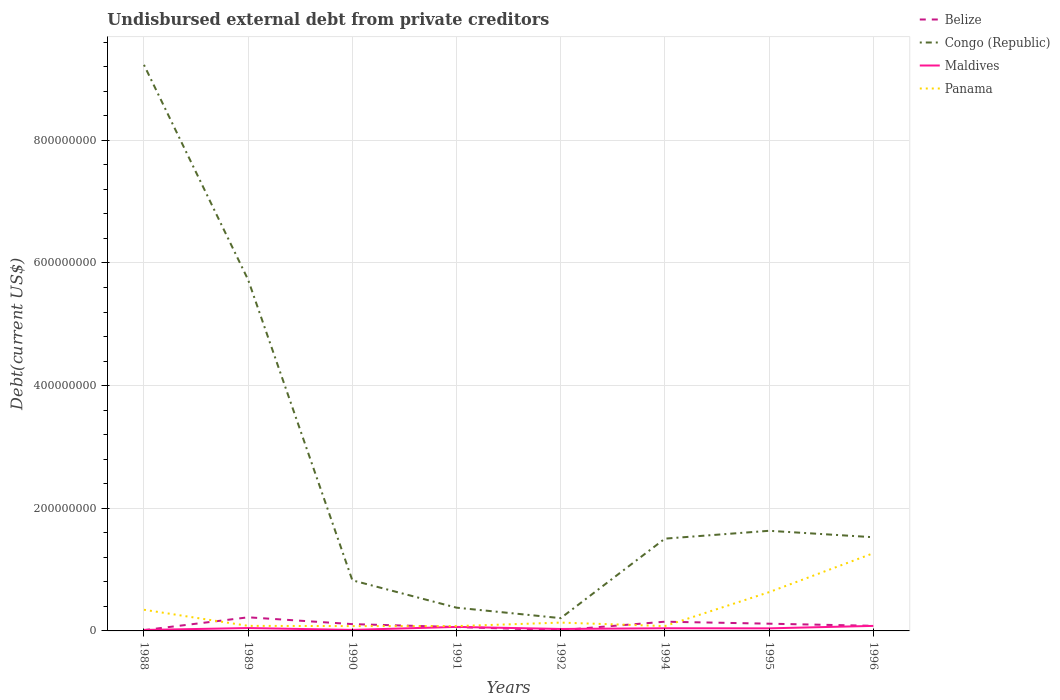Does the line corresponding to Belize intersect with the line corresponding to Panama?
Offer a very short reply. Yes. Is the number of lines equal to the number of legend labels?
Ensure brevity in your answer.  Yes. Across all years, what is the maximum total debt in Belize?
Make the answer very short. 1.24e+06. In which year was the total debt in Belize maximum?
Provide a succinct answer. 1992. What is the total total debt in Congo (Republic) in the graph?
Offer a terse response. 4.46e+07. What is the difference between the highest and the second highest total debt in Belize?
Offer a terse response. 2.10e+07. Is the total debt in Maldives strictly greater than the total debt in Congo (Republic) over the years?
Make the answer very short. Yes. How many lines are there?
Your answer should be compact. 4. What is the difference between two consecutive major ticks on the Y-axis?
Offer a terse response. 2.00e+08. Are the values on the major ticks of Y-axis written in scientific E-notation?
Provide a succinct answer. No. Does the graph contain any zero values?
Ensure brevity in your answer.  No. How are the legend labels stacked?
Ensure brevity in your answer.  Vertical. What is the title of the graph?
Provide a succinct answer. Undisbursed external debt from private creditors. What is the label or title of the X-axis?
Your answer should be compact. Years. What is the label or title of the Y-axis?
Ensure brevity in your answer.  Debt(current US$). What is the Debt(current US$) in Belize in 1988?
Keep it short and to the point. 1.32e+06. What is the Debt(current US$) in Congo (Republic) in 1988?
Offer a terse response. 9.23e+08. What is the Debt(current US$) in Maldives in 1988?
Provide a succinct answer. 1.58e+06. What is the Debt(current US$) of Panama in 1988?
Your answer should be very brief. 3.45e+07. What is the Debt(current US$) in Belize in 1989?
Keep it short and to the point. 2.22e+07. What is the Debt(current US$) of Congo (Republic) in 1989?
Your answer should be very brief. 5.72e+08. What is the Debt(current US$) of Maldives in 1989?
Your answer should be very brief. 4.68e+06. What is the Debt(current US$) of Panama in 1989?
Make the answer very short. 8.26e+06. What is the Debt(current US$) of Belize in 1990?
Keep it short and to the point. 1.11e+07. What is the Debt(current US$) of Congo (Republic) in 1990?
Your response must be concise. 8.25e+07. What is the Debt(current US$) of Maldives in 1990?
Keep it short and to the point. 1.69e+06. What is the Debt(current US$) in Panama in 1990?
Your response must be concise. 7.85e+06. What is the Debt(current US$) in Belize in 1991?
Give a very brief answer. 6.34e+06. What is the Debt(current US$) of Congo (Republic) in 1991?
Your response must be concise. 3.79e+07. What is the Debt(current US$) in Maldives in 1991?
Ensure brevity in your answer.  6.54e+06. What is the Debt(current US$) in Panama in 1991?
Your answer should be compact. 7.85e+06. What is the Debt(current US$) of Belize in 1992?
Give a very brief answer. 1.24e+06. What is the Debt(current US$) in Congo (Republic) in 1992?
Offer a terse response. 2.08e+07. What is the Debt(current US$) of Maldives in 1992?
Your answer should be very brief. 3.19e+06. What is the Debt(current US$) of Panama in 1992?
Ensure brevity in your answer.  1.36e+07. What is the Debt(current US$) in Belize in 1994?
Keep it short and to the point. 1.50e+07. What is the Debt(current US$) in Congo (Republic) in 1994?
Ensure brevity in your answer.  1.50e+08. What is the Debt(current US$) in Maldives in 1994?
Offer a very short reply. 4.35e+06. What is the Debt(current US$) in Panama in 1994?
Make the answer very short. 7.92e+06. What is the Debt(current US$) of Belize in 1995?
Your answer should be very brief. 1.18e+07. What is the Debt(current US$) in Congo (Republic) in 1995?
Your response must be concise. 1.63e+08. What is the Debt(current US$) in Maldives in 1995?
Make the answer very short. 4.20e+06. What is the Debt(current US$) of Panama in 1995?
Make the answer very short. 6.32e+07. What is the Debt(current US$) in Belize in 1996?
Your response must be concise. 8.32e+06. What is the Debt(current US$) in Congo (Republic) in 1996?
Give a very brief answer. 1.53e+08. What is the Debt(current US$) in Maldives in 1996?
Keep it short and to the point. 8.20e+06. What is the Debt(current US$) of Panama in 1996?
Offer a terse response. 1.27e+08. Across all years, what is the maximum Debt(current US$) in Belize?
Offer a terse response. 2.22e+07. Across all years, what is the maximum Debt(current US$) in Congo (Republic)?
Keep it short and to the point. 9.23e+08. Across all years, what is the maximum Debt(current US$) in Maldives?
Your response must be concise. 8.20e+06. Across all years, what is the maximum Debt(current US$) of Panama?
Give a very brief answer. 1.27e+08. Across all years, what is the minimum Debt(current US$) of Belize?
Your answer should be very brief. 1.24e+06. Across all years, what is the minimum Debt(current US$) in Congo (Republic)?
Keep it short and to the point. 2.08e+07. Across all years, what is the minimum Debt(current US$) in Maldives?
Ensure brevity in your answer.  1.58e+06. Across all years, what is the minimum Debt(current US$) in Panama?
Offer a very short reply. 7.85e+06. What is the total Debt(current US$) in Belize in the graph?
Offer a terse response. 7.74e+07. What is the total Debt(current US$) in Congo (Republic) in the graph?
Your answer should be compact. 2.10e+09. What is the total Debt(current US$) in Maldives in the graph?
Offer a terse response. 3.44e+07. What is the total Debt(current US$) in Panama in the graph?
Offer a terse response. 2.70e+08. What is the difference between the Debt(current US$) of Belize in 1988 and that in 1989?
Provide a succinct answer. -2.09e+07. What is the difference between the Debt(current US$) of Congo (Republic) in 1988 and that in 1989?
Provide a succinct answer. 3.51e+08. What is the difference between the Debt(current US$) in Maldives in 1988 and that in 1989?
Ensure brevity in your answer.  -3.10e+06. What is the difference between the Debt(current US$) of Panama in 1988 and that in 1989?
Your response must be concise. 2.62e+07. What is the difference between the Debt(current US$) of Belize in 1988 and that in 1990?
Your response must be concise. -9.77e+06. What is the difference between the Debt(current US$) of Congo (Republic) in 1988 and that in 1990?
Make the answer very short. 8.41e+08. What is the difference between the Debt(current US$) of Maldives in 1988 and that in 1990?
Offer a terse response. -1.04e+05. What is the difference between the Debt(current US$) of Panama in 1988 and that in 1990?
Offer a very short reply. 2.67e+07. What is the difference between the Debt(current US$) in Belize in 1988 and that in 1991?
Give a very brief answer. -5.02e+06. What is the difference between the Debt(current US$) in Congo (Republic) in 1988 and that in 1991?
Make the answer very short. 8.85e+08. What is the difference between the Debt(current US$) of Maldives in 1988 and that in 1991?
Your answer should be very brief. -4.96e+06. What is the difference between the Debt(current US$) of Panama in 1988 and that in 1991?
Make the answer very short. 2.67e+07. What is the difference between the Debt(current US$) in Belize in 1988 and that in 1992?
Your response must be concise. 8.10e+04. What is the difference between the Debt(current US$) in Congo (Republic) in 1988 and that in 1992?
Keep it short and to the point. 9.02e+08. What is the difference between the Debt(current US$) of Maldives in 1988 and that in 1992?
Provide a short and direct response. -1.60e+06. What is the difference between the Debt(current US$) of Panama in 1988 and that in 1992?
Provide a succinct answer. 2.09e+07. What is the difference between the Debt(current US$) in Belize in 1988 and that in 1994?
Provide a succinct answer. -1.37e+07. What is the difference between the Debt(current US$) of Congo (Republic) in 1988 and that in 1994?
Give a very brief answer. 7.73e+08. What is the difference between the Debt(current US$) of Maldives in 1988 and that in 1994?
Make the answer very short. -2.76e+06. What is the difference between the Debt(current US$) of Panama in 1988 and that in 1994?
Keep it short and to the point. 2.66e+07. What is the difference between the Debt(current US$) of Belize in 1988 and that in 1995?
Provide a succinct answer. -1.05e+07. What is the difference between the Debt(current US$) in Congo (Republic) in 1988 and that in 1995?
Offer a terse response. 7.60e+08. What is the difference between the Debt(current US$) of Maldives in 1988 and that in 1995?
Offer a terse response. -2.61e+06. What is the difference between the Debt(current US$) in Panama in 1988 and that in 1995?
Your answer should be compact. -2.87e+07. What is the difference between the Debt(current US$) of Belize in 1988 and that in 1996?
Provide a succinct answer. -7.00e+06. What is the difference between the Debt(current US$) of Congo (Republic) in 1988 and that in 1996?
Your answer should be very brief. 7.70e+08. What is the difference between the Debt(current US$) of Maldives in 1988 and that in 1996?
Your answer should be very brief. -6.62e+06. What is the difference between the Debt(current US$) in Panama in 1988 and that in 1996?
Offer a terse response. -9.22e+07. What is the difference between the Debt(current US$) of Belize in 1989 and that in 1990?
Keep it short and to the point. 1.11e+07. What is the difference between the Debt(current US$) of Congo (Republic) in 1989 and that in 1990?
Ensure brevity in your answer.  4.90e+08. What is the difference between the Debt(current US$) of Maldives in 1989 and that in 1990?
Provide a succinct answer. 3.00e+06. What is the difference between the Debt(current US$) in Panama in 1989 and that in 1990?
Your answer should be compact. 4.11e+05. What is the difference between the Debt(current US$) of Belize in 1989 and that in 1991?
Make the answer very short. 1.59e+07. What is the difference between the Debt(current US$) of Congo (Republic) in 1989 and that in 1991?
Provide a succinct answer. 5.35e+08. What is the difference between the Debt(current US$) of Maldives in 1989 and that in 1991?
Ensure brevity in your answer.  -1.86e+06. What is the difference between the Debt(current US$) of Panama in 1989 and that in 1991?
Ensure brevity in your answer.  4.18e+05. What is the difference between the Debt(current US$) in Belize in 1989 and that in 1992?
Make the answer very short. 2.10e+07. What is the difference between the Debt(current US$) of Congo (Republic) in 1989 and that in 1992?
Provide a succinct answer. 5.52e+08. What is the difference between the Debt(current US$) of Maldives in 1989 and that in 1992?
Give a very brief answer. 1.50e+06. What is the difference between the Debt(current US$) of Panama in 1989 and that in 1992?
Your response must be concise. -5.31e+06. What is the difference between the Debt(current US$) of Belize in 1989 and that in 1994?
Ensure brevity in your answer.  7.16e+06. What is the difference between the Debt(current US$) of Congo (Republic) in 1989 and that in 1994?
Your answer should be compact. 4.22e+08. What is the difference between the Debt(current US$) of Maldives in 1989 and that in 1994?
Provide a succinct answer. 3.34e+05. What is the difference between the Debt(current US$) of Panama in 1989 and that in 1994?
Give a very brief answer. 3.43e+05. What is the difference between the Debt(current US$) of Belize in 1989 and that in 1995?
Your answer should be very brief. 1.04e+07. What is the difference between the Debt(current US$) in Congo (Republic) in 1989 and that in 1995?
Your answer should be compact. 4.09e+08. What is the difference between the Debt(current US$) in Maldives in 1989 and that in 1995?
Provide a short and direct response. 4.89e+05. What is the difference between the Debt(current US$) of Panama in 1989 and that in 1995?
Your response must be concise. -5.50e+07. What is the difference between the Debt(current US$) of Belize in 1989 and that in 1996?
Offer a terse response. 1.39e+07. What is the difference between the Debt(current US$) of Congo (Republic) in 1989 and that in 1996?
Your answer should be compact. 4.20e+08. What is the difference between the Debt(current US$) of Maldives in 1989 and that in 1996?
Give a very brief answer. -3.52e+06. What is the difference between the Debt(current US$) of Panama in 1989 and that in 1996?
Offer a very short reply. -1.18e+08. What is the difference between the Debt(current US$) of Belize in 1990 and that in 1991?
Your response must be concise. 4.75e+06. What is the difference between the Debt(current US$) in Congo (Republic) in 1990 and that in 1991?
Offer a terse response. 4.46e+07. What is the difference between the Debt(current US$) of Maldives in 1990 and that in 1991?
Offer a very short reply. -4.85e+06. What is the difference between the Debt(current US$) in Panama in 1990 and that in 1991?
Offer a terse response. 7000. What is the difference between the Debt(current US$) of Belize in 1990 and that in 1992?
Ensure brevity in your answer.  9.85e+06. What is the difference between the Debt(current US$) in Congo (Republic) in 1990 and that in 1992?
Provide a succinct answer. 6.17e+07. What is the difference between the Debt(current US$) in Maldives in 1990 and that in 1992?
Offer a very short reply. -1.50e+06. What is the difference between the Debt(current US$) in Panama in 1990 and that in 1992?
Offer a very short reply. -5.72e+06. What is the difference between the Debt(current US$) of Belize in 1990 and that in 1994?
Offer a terse response. -3.96e+06. What is the difference between the Debt(current US$) in Congo (Republic) in 1990 and that in 1994?
Make the answer very short. -6.80e+07. What is the difference between the Debt(current US$) of Maldives in 1990 and that in 1994?
Keep it short and to the point. -2.66e+06. What is the difference between the Debt(current US$) in Panama in 1990 and that in 1994?
Provide a short and direct response. -6.80e+04. What is the difference between the Debt(current US$) of Belize in 1990 and that in 1995?
Your response must be concise. -7.07e+05. What is the difference between the Debt(current US$) in Congo (Republic) in 1990 and that in 1995?
Offer a very short reply. -8.08e+07. What is the difference between the Debt(current US$) of Maldives in 1990 and that in 1995?
Give a very brief answer. -2.51e+06. What is the difference between the Debt(current US$) in Panama in 1990 and that in 1995?
Your answer should be very brief. -5.54e+07. What is the difference between the Debt(current US$) in Belize in 1990 and that in 1996?
Offer a terse response. 2.77e+06. What is the difference between the Debt(current US$) of Congo (Republic) in 1990 and that in 1996?
Make the answer very short. -7.03e+07. What is the difference between the Debt(current US$) in Maldives in 1990 and that in 1996?
Provide a short and direct response. -6.51e+06. What is the difference between the Debt(current US$) of Panama in 1990 and that in 1996?
Your answer should be compact. -1.19e+08. What is the difference between the Debt(current US$) of Belize in 1991 and that in 1992?
Provide a short and direct response. 5.10e+06. What is the difference between the Debt(current US$) of Congo (Republic) in 1991 and that in 1992?
Make the answer very short. 1.71e+07. What is the difference between the Debt(current US$) in Maldives in 1991 and that in 1992?
Offer a very short reply. 3.35e+06. What is the difference between the Debt(current US$) of Panama in 1991 and that in 1992?
Make the answer very short. -5.73e+06. What is the difference between the Debt(current US$) of Belize in 1991 and that in 1994?
Offer a terse response. -8.70e+06. What is the difference between the Debt(current US$) of Congo (Republic) in 1991 and that in 1994?
Offer a very short reply. -1.13e+08. What is the difference between the Debt(current US$) in Maldives in 1991 and that in 1994?
Your answer should be compact. 2.19e+06. What is the difference between the Debt(current US$) of Panama in 1991 and that in 1994?
Keep it short and to the point. -7.50e+04. What is the difference between the Debt(current US$) in Belize in 1991 and that in 1995?
Your response must be concise. -5.46e+06. What is the difference between the Debt(current US$) in Congo (Republic) in 1991 and that in 1995?
Offer a terse response. -1.25e+08. What is the difference between the Debt(current US$) of Maldives in 1991 and that in 1995?
Offer a very short reply. 2.35e+06. What is the difference between the Debt(current US$) in Panama in 1991 and that in 1995?
Provide a succinct answer. -5.54e+07. What is the difference between the Debt(current US$) in Belize in 1991 and that in 1996?
Your answer should be very brief. -1.98e+06. What is the difference between the Debt(current US$) in Congo (Republic) in 1991 and that in 1996?
Keep it short and to the point. -1.15e+08. What is the difference between the Debt(current US$) of Maldives in 1991 and that in 1996?
Your answer should be very brief. -1.66e+06. What is the difference between the Debt(current US$) in Panama in 1991 and that in 1996?
Your response must be concise. -1.19e+08. What is the difference between the Debt(current US$) of Belize in 1992 and that in 1994?
Offer a very short reply. -1.38e+07. What is the difference between the Debt(current US$) of Congo (Republic) in 1992 and that in 1994?
Provide a short and direct response. -1.30e+08. What is the difference between the Debt(current US$) of Maldives in 1992 and that in 1994?
Your response must be concise. -1.16e+06. What is the difference between the Debt(current US$) of Panama in 1992 and that in 1994?
Offer a very short reply. 5.66e+06. What is the difference between the Debt(current US$) of Belize in 1992 and that in 1995?
Your response must be concise. -1.06e+07. What is the difference between the Debt(current US$) in Congo (Republic) in 1992 and that in 1995?
Ensure brevity in your answer.  -1.42e+08. What is the difference between the Debt(current US$) of Maldives in 1992 and that in 1995?
Keep it short and to the point. -1.01e+06. What is the difference between the Debt(current US$) of Panama in 1992 and that in 1995?
Your answer should be compact. -4.96e+07. What is the difference between the Debt(current US$) in Belize in 1992 and that in 1996?
Your response must be concise. -7.08e+06. What is the difference between the Debt(current US$) of Congo (Republic) in 1992 and that in 1996?
Your response must be concise. -1.32e+08. What is the difference between the Debt(current US$) in Maldives in 1992 and that in 1996?
Offer a very short reply. -5.01e+06. What is the difference between the Debt(current US$) of Panama in 1992 and that in 1996?
Your response must be concise. -1.13e+08. What is the difference between the Debt(current US$) of Belize in 1994 and that in 1995?
Your answer should be compact. 3.25e+06. What is the difference between the Debt(current US$) in Congo (Republic) in 1994 and that in 1995?
Your answer should be very brief. -1.28e+07. What is the difference between the Debt(current US$) in Maldives in 1994 and that in 1995?
Give a very brief answer. 1.55e+05. What is the difference between the Debt(current US$) in Panama in 1994 and that in 1995?
Give a very brief answer. -5.53e+07. What is the difference between the Debt(current US$) in Belize in 1994 and that in 1996?
Offer a terse response. 6.72e+06. What is the difference between the Debt(current US$) in Congo (Republic) in 1994 and that in 1996?
Provide a succinct answer. -2.27e+06. What is the difference between the Debt(current US$) in Maldives in 1994 and that in 1996?
Make the answer very short. -3.85e+06. What is the difference between the Debt(current US$) of Panama in 1994 and that in 1996?
Keep it short and to the point. -1.19e+08. What is the difference between the Debt(current US$) of Belize in 1995 and that in 1996?
Provide a succinct answer. 3.47e+06. What is the difference between the Debt(current US$) of Congo (Republic) in 1995 and that in 1996?
Offer a very short reply. 1.05e+07. What is the difference between the Debt(current US$) of Maldives in 1995 and that in 1996?
Your answer should be very brief. -4.01e+06. What is the difference between the Debt(current US$) in Panama in 1995 and that in 1996?
Your answer should be very brief. -6.35e+07. What is the difference between the Debt(current US$) in Belize in 1988 and the Debt(current US$) in Congo (Republic) in 1989?
Offer a very short reply. -5.71e+08. What is the difference between the Debt(current US$) in Belize in 1988 and the Debt(current US$) in Maldives in 1989?
Provide a succinct answer. -3.36e+06. What is the difference between the Debt(current US$) of Belize in 1988 and the Debt(current US$) of Panama in 1989?
Offer a very short reply. -6.94e+06. What is the difference between the Debt(current US$) of Congo (Republic) in 1988 and the Debt(current US$) of Maldives in 1989?
Provide a succinct answer. 9.18e+08. What is the difference between the Debt(current US$) of Congo (Republic) in 1988 and the Debt(current US$) of Panama in 1989?
Give a very brief answer. 9.15e+08. What is the difference between the Debt(current US$) of Maldives in 1988 and the Debt(current US$) of Panama in 1989?
Provide a succinct answer. -6.68e+06. What is the difference between the Debt(current US$) in Belize in 1988 and the Debt(current US$) in Congo (Republic) in 1990?
Make the answer very short. -8.12e+07. What is the difference between the Debt(current US$) in Belize in 1988 and the Debt(current US$) in Maldives in 1990?
Your response must be concise. -3.68e+05. What is the difference between the Debt(current US$) in Belize in 1988 and the Debt(current US$) in Panama in 1990?
Your answer should be very brief. -6.53e+06. What is the difference between the Debt(current US$) of Congo (Republic) in 1988 and the Debt(current US$) of Maldives in 1990?
Ensure brevity in your answer.  9.21e+08. What is the difference between the Debt(current US$) in Congo (Republic) in 1988 and the Debt(current US$) in Panama in 1990?
Provide a succinct answer. 9.15e+08. What is the difference between the Debt(current US$) of Maldives in 1988 and the Debt(current US$) of Panama in 1990?
Offer a terse response. -6.27e+06. What is the difference between the Debt(current US$) in Belize in 1988 and the Debt(current US$) in Congo (Republic) in 1991?
Give a very brief answer. -3.66e+07. What is the difference between the Debt(current US$) of Belize in 1988 and the Debt(current US$) of Maldives in 1991?
Your answer should be compact. -5.22e+06. What is the difference between the Debt(current US$) in Belize in 1988 and the Debt(current US$) in Panama in 1991?
Your answer should be compact. -6.53e+06. What is the difference between the Debt(current US$) in Congo (Republic) in 1988 and the Debt(current US$) in Maldives in 1991?
Ensure brevity in your answer.  9.16e+08. What is the difference between the Debt(current US$) in Congo (Republic) in 1988 and the Debt(current US$) in Panama in 1991?
Make the answer very short. 9.15e+08. What is the difference between the Debt(current US$) in Maldives in 1988 and the Debt(current US$) in Panama in 1991?
Ensure brevity in your answer.  -6.26e+06. What is the difference between the Debt(current US$) in Belize in 1988 and the Debt(current US$) in Congo (Republic) in 1992?
Your response must be concise. -1.95e+07. What is the difference between the Debt(current US$) in Belize in 1988 and the Debt(current US$) in Maldives in 1992?
Your answer should be compact. -1.87e+06. What is the difference between the Debt(current US$) in Belize in 1988 and the Debt(current US$) in Panama in 1992?
Your response must be concise. -1.23e+07. What is the difference between the Debt(current US$) of Congo (Republic) in 1988 and the Debt(current US$) of Maldives in 1992?
Provide a succinct answer. 9.20e+08. What is the difference between the Debt(current US$) in Congo (Republic) in 1988 and the Debt(current US$) in Panama in 1992?
Keep it short and to the point. 9.09e+08. What is the difference between the Debt(current US$) in Maldives in 1988 and the Debt(current US$) in Panama in 1992?
Make the answer very short. -1.20e+07. What is the difference between the Debt(current US$) of Belize in 1988 and the Debt(current US$) of Congo (Republic) in 1994?
Offer a terse response. -1.49e+08. What is the difference between the Debt(current US$) of Belize in 1988 and the Debt(current US$) of Maldives in 1994?
Make the answer very short. -3.03e+06. What is the difference between the Debt(current US$) of Belize in 1988 and the Debt(current US$) of Panama in 1994?
Your answer should be very brief. -6.60e+06. What is the difference between the Debt(current US$) of Congo (Republic) in 1988 and the Debt(current US$) of Maldives in 1994?
Your answer should be compact. 9.19e+08. What is the difference between the Debt(current US$) of Congo (Republic) in 1988 and the Debt(current US$) of Panama in 1994?
Give a very brief answer. 9.15e+08. What is the difference between the Debt(current US$) in Maldives in 1988 and the Debt(current US$) in Panama in 1994?
Your response must be concise. -6.34e+06. What is the difference between the Debt(current US$) in Belize in 1988 and the Debt(current US$) in Congo (Republic) in 1995?
Offer a terse response. -1.62e+08. What is the difference between the Debt(current US$) in Belize in 1988 and the Debt(current US$) in Maldives in 1995?
Ensure brevity in your answer.  -2.87e+06. What is the difference between the Debt(current US$) in Belize in 1988 and the Debt(current US$) in Panama in 1995?
Ensure brevity in your answer.  -6.19e+07. What is the difference between the Debt(current US$) of Congo (Republic) in 1988 and the Debt(current US$) of Maldives in 1995?
Your answer should be compact. 9.19e+08. What is the difference between the Debt(current US$) of Congo (Republic) in 1988 and the Debt(current US$) of Panama in 1995?
Your answer should be very brief. 8.60e+08. What is the difference between the Debt(current US$) in Maldives in 1988 and the Debt(current US$) in Panama in 1995?
Your answer should be very brief. -6.16e+07. What is the difference between the Debt(current US$) of Belize in 1988 and the Debt(current US$) of Congo (Republic) in 1996?
Keep it short and to the point. -1.51e+08. What is the difference between the Debt(current US$) of Belize in 1988 and the Debt(current US$) of Maldives in 1996?
Your response must be concise. -6.88e+06. What is the difference between the Debt(current US$) in Belize in 1988 and the Debt(current US$) in Panama in 1996?
Provide a succinct answer. -1.25e+08. What is the difference between the Debt(current US$) of Congo (Republic) in 1988 and the Debt(current US$) of Maldives in 1996?
Your answer should be very brief. 9.15e+08. What is the difference between the Debt(current US$) of Congo (Republic) in 1988 and the Debt(current US$) of Panama in 1996?
Offer a terse response. 7.96e+08. What is the difference between the Debt(current US$) of Maldives in 1988 and the Debt(current US$) of Panama in 1996?
Provide a succinct answer. -1.25e+08. What is the difference between the Debt(current US$) of Belize in 1989 and the Debt(current US$) of Congo (Republic) in 1990?
Make the answer very short. -6.03e+07. What is the difference between the Debt(current US$) in Belize in 1989 and the Debt(current US$) in Maldives in 1990?
Offer a very short reply. 2.05e+07. What is the difference between the Debt(current US$) in Belize in 1989 and the Debt(current US$) in Panama in 1990?
Your answer should be compact. 1.43e+07. What is the difference between the Debt(current US$) in Congo (Republic) in 1989 and the Debt(current US$) in Maldives in 1990?
Offer a terse response. 5.71e+08. What is the difference between the Debt(current US$) of Congo (Republic) in 1989 and the Debt(current US$) of Panama in 1990?
Your answer should be compact. 5.65e+08. What is the difference between the Debt(current US$) in Maldives in 1989 and the Debt(current US$) in Panama in 1990?
Your answer should be very brief. -3.17e+06. What is the difference between the Debt(current US$) of Belize in 1989 and the Debt(current US$) of Congo (Republic) in 1991?
Provide a succinct answer. -1.57e+07. What is the difference between the Debt(current US$) in Belize in 1989 and the Debt(current US$) in Maldives in 1991?
Keep it short and to the point. 1.57e+07. What is the difference between the Debt(current US$) of Belize in 1989 and the Debt(current US$) of Panama in 1991?
Offer a terse response. 1.44e+07. What is the difference between the Debt(current US$) of Congo (Republic) in 1989 and the Debt(current US$) of Maldives in 1991?
Your answer should be compact. 5.66e+08. What is the difference between the Debt(current US$) of Congo (Republic) in 1989 and the Debt(current US$) of Panama in 1991?
Make the answer very short. 5.65e+08. What is the difference between the Debt(current US$) in Maldives in 1989 and the Debt(current US$) in Panama in 1991?
Give a very brief answer. -3.16e+06. What is the difference between the Debt(current US$) in Belize in 1989 and the Debt(current US$) in Congo (Republic) in 1992?
Keep it short and to the point. 1.36e+06. What is the difference between the Debt(current US$) of Belize in 1989 and the Debt(current US$) of Maldives in 1992?
Make the answer very short. 1.90e+07. What is the difference between the Debt(current US$) in Belize in 1989 and the Debt(current US$) in Panama in 1992?
Give a very brief answer. 8.62e+06. What is the difference between the Debt(current US$) of Congo (Republic) in 1989 and the Debt(current US$) of Maldives in 1992?
Give a very brief answer. 5.69e+08. What is the difference between the Debt(current US$) in Congo (Republic) in 1989 and the Debt(current US$) in Panama in 1992?
Give a very brief answer. 5.59e+08. What is the difference between the Debt(current US$) of Maldives in 1989 and the Debt(current US$) of Panama in 1992?
Give a very brief answer. -8.89e+06. What is the difference between the Debt(current US$) of Belize in 1989 and the Debt(current US$) of Congo (Republic) in 1994?
Your response must be concise. -1.28e+08. What is the difference between the Debt(current US$) of Belize in 1989 and the Debt(current US$) of Maldives in 1994?
Your response must be concise. 1.78e+07. What is the difference between the Debt(current US$) of Belize in 1989 and the Debt(current US$) of Panama in 1994?
Your answer should be compact. 1.43e+07. What is the difference between the Debt(current US$) of Congo (Republic) in 1989 and the Debt(current US$) of Maldives in 1994?
Provide a short and direct response. 5.68e+08. What is the difference between the Debt(current US$) of Congo (Republic) in 1989 and the Debt(current US$) of Panama in 1994?
Your response must be concise. 5.65e+08. What is the difference between the Debt(current US$) of Maldives in 1989 and the Debt(current US$) of Panama in 1994?
Give a very brief answer. -3.24e+06. What is the difference between the Debt(current US$) in Belize in 1989 and the Debt(current US$) in Congo (Republic) in 1995?
Ensure brevity in your answer.  -1.41e+08. What is the difference between the Debt(current US$) of Belize in 1989 and the Debt(current US$) of Maldives in 1995?
Provide a short and direct response. 1.80e+07. What is the difference between the Debt(current US$) in Belize in 1989 and the Debt(current US$) in Panama in 1995?
Make the answer very short. -4.10e+07. What is the difference between the Debt(current US$) in Congo (Republic) in 1989 and the Debt(current US$) in Maldives in 1995?
Ensure brevity in your answer.  5.68e+08. What is the difference between the Debt(current US$) in Congo (Republic) in 1989 and the Debt(current US$) in Panama in 1995?
Give a very brief answer. 5.09e+08. What is the difference between the Debt(current US$) of Maldives in 1989 and the Debt(current US$) of Panama in 1995?
Ensure brevity in your answer.  -5.85e+07. What is the difference between the Debt(current US$) of Belize in 1989 and the Debt(current US$) of Congo (Republic) in 1996?
Offer a very short reply. -1.31e+08. What is the difference between the Debt(current US$) of Belize in 1989 and the Debt(current US$) of Maldives in 1996?
Provide a short and direct response. 1.40e+07. What is the difference between the Debt(current US$) in Belize in 1989 and the Debt(current US$) in Panama in 1996?
Provide a short and direct response. -1.04e+08. What is the difference between the Debt(current US$) of Congo (Republic) in 1989 and the Debt(current US$) of Maldives in 1996?
Your response must be concise. 5.64e+08. What is the difference between the Debt(current US$) of Congo (Republic) in 1989 and the Debt(current US$) of Panama in 1996?
Your answer should be compact. 4.46e+08. What is the difference between the Debt(current US$) in Maldives in 1989 and the Debt(current US$) in Panama in 1996?
Keep it short and to the point. -1.22e+08. What is the difference between the Debt(current US$) of Belize in 1990 and the Debt(current US$) of Congo (Republic) in 1991?
Offer a terse response. -2.68e+07. What is the difference between the Debt(current US$) of Belize in 1990 and the Debt(current US$) of Maldives in 1991?
Provide a succinct answer. 4.55e+06. What is the difference between the Debt(current US$) of Belize in 1990 and the Debt(current US$) of Panama in 1991?
Give a very brief answer. 3.24e+06. What is the difference between the Debt(current US$) of Congo (Republic) in 1990 and the Debt(current US$) of Maldives in 1991?
Make the answer very short. 7.60e+07. What is the difference between the Debt(current US$) in Congo (Republic) in 1990 and the Debt(current US$) in Panama in 1991?
Your answer should be compact. 7.47e+07. What is the difference between the Debt(current US$) in Maldives in 1990 and the Debt(current US$) in Panama in 1991?
Make the answer very short. -6.16e+06. What is the difference between the Debt(current US$) of Belize in 1990 and the Debt(current US$) of Congo (Republic) in 1992?
Provide a succinct answer. -9.75e+06. What is the difference between the Debt(current US$) in Belize in 1990 and the Debt(current US$) in Maldives in 1992?
Offer a terse response. 7.90e+06. What is the difference between the Debt(current US$) of Belize in 1990 and the Debt(current US$) of Panama in 1992?
Your answer should be very brief. -2.49e+06. What is the difference between the Debt(current US$) in Congo (Republic) in 1990 and the Debt(current US$) in Maldives in 1992?
Your response must be concise. 7.93e+07. What is the difference between the Debt(current US$) in Congo (Republic) in 1990 and the Debt(current US$) in Panama in 1992?
Ensure brevity in your answer.  6.89e+07. What is the difference between the Debt(current US$) of Maldives in 1990 and the Debt(current US$) of Panama in 1992?
Provide a succinct answer. -1.19e+07. What is the difference between the Debt(current US$) in Belize in 1990 and the Debt(current US$) in Congo (Republic) in 1994?
Keep it short and to the point. -1.39e+08. What is the difference between the Debt(current US$) in Belize in 1990 and the Debt(current US$) in Maldives in 1994?
Your response must be concise. 6.74e+06. What is the difference between the Debt(current US$) in Belize in 1990 and the Debt(current US$) in Panama in 1994?
Your answer should be compact. 3.17e+06. What is the difference between the Debt(current US$) in Congo (Republic) in 1990 and the Debt(current US$) in Maldives in 1994?
Your answer should be very brief. 7.82e+07. What is the difference between the Debt(current US$) in Congo (Republic) in 1990 and the Debt(current US$) in Panama in 1994?
Your response must be concise. 7.46e+07. What is the difference between the Debt(current US$) of Maldives in 1990 and the Debt(current US$) of Panama in 1994?
Your answer should be compact. -6.23e+06. What is the difference between the Debt(current US$) of Belize in 1990 and the Debt(current US$) of Congo (Republic) in 1995?
Ensure brevity in your answer.  -1.52e+08. What is the difference between the Debt(current US$) of Belize in 1990 and the Debt(current US$) of Maldives in 1995?
Provide a succinct answer. 6.90e+06. What is the difference between the Debt(current US$) of Belize in 1990 and the Debt(current US$) of Panama in 1995?
Ensure brevity in your answer.  -5.21e+07. What is the difference between the Debt(current US$) in Congo (Republic) in 1990 and the Debt(current US$) in Maldives in 1995?
Your answer should be very brief. 7.83e+07. What is the difference between the Debt(current US$) of Congo (Republic) in 1990 and the Debt(current US$) of Panama in 1995?
Give a very brief answer. 1.93e+07. What is the difference between the Debt(current US$) in Maldives in 1990 and the Debt(current US$) in Panama in 1995?
Provide a succinct answer. -6.15e+07. What is the difference between the Debt(current US$) in Belize in 1990 and the Debt(current US$) in Congo (Republic) in 1996?
Provide a short and direct response. -1.42e+08. What is the difference between the Debt(current US$) of Belize in 1990 and the Debt(current US$) of Maldives in 1996?
Offer a very short reply. 2.89e+06. What is the difference between the Debt(current US$) in Belize in 1990 and the Debt(current US$) in Panama in 1996?
Your answer should be very brief. -1.16e+08. What is the difference between the Debt(current US$) of Congo (Republic) in 1990 and the Debt(current US$) of Maldives in 1996?
Provide a succinct answer. 7.43e+07. What is the difference between the Debt(current US$) in Congo (Republic) in 1990 and the Debt(current US$) in Panama in 1996?
Your response must be concise. -4.42e+07. What is the difference between the Debt(current US$) in Maldives in 1990 and the Debt(current US$) in Panama in 1996?
Provide a short and direct response. -1.25e+08. What is the difference between the Debt(current US$) in Belize in 1991 and the Debt(current US$) in Congo (Republic) in 1992?
Keep it short and to the point. -1.45e+07. What is the difference between the Debt(current US$) in Belize in 1991 and the Debt(current US$) in Maldives in 1992?
Provide a short and direct response. 3.15e+06. What is the difference between the Debt(current US$) of Belize in 1991 and the Debt(current US$) of Panama in 1992?
Keep it short and to the point. -7.24e+06. What is the difference between the Debt(current US$) of Congo (Republic) in 1991 and the Debt(current US$) of Maldives in 1992?
Provide a short and direct response. 3.47e+07. What is the difference between the Debt(current US$) of Congo (Republic) in 1991 and the Debt(current US$) of Panama in 1992?
Your response must be concise. 2.43e+07. What is the difference between the Debt(current US$) of Maldives in 1991 and the Debt(current US$) of Panama in 1992?
Your answer should be very brief. -7.04e+06. What is the difference between the Debt(current US$) of Belize in 1991 and the Debt(current US$) of Congo (Republic) in 1994?
Provide a short and direct response. -1.44e+08. What is the difference between the Debt(current US$) of Belize in 1991 and the Debt(current US$) of Maldives in 1994?
Make the answer very short. 1.99e+06. What is the difference between the Debt(current US$) of Belize in 1991 and the Debt(current US$) of Panama in 1994?
Ensure brevity in your answer.  -1.58e+06. What is the difference between the Debt(current US$) of Congo (Republic) in 1991 and the Debt(current US$) of Maldives in 1994?
Offer a very short reply. 3.36e+07. What is the difference between the Debt(current US$) in Congo (Republic) in 1991 and the Debt(current US$) in Panama in 1994?
Offer a very short reply. 3.00e+07. What is the difference between the Debt(current US$) of Maldives in 1991 and the Debt(current US$) of Panama in 1994?
Give a very brief answer. -1.38e+06. What is the difference between the Debt(current US$) of Belize in 1991 and the Debt(current US$) of Congo (Republic) in 1995?
Your answer should be compact. -1.57e+08. What is the difference between the Debt(current US$) in Belize in 1991 and the Debt(current US$) in Maldives in 1995?
Provide a succinct answer. 2.14e+06. What is the difference between the Debt(current US$) in Belize in 1991 and the Debt(current US$) in Panama in 1995?
Make the answer very short. -5.69e+07. What is the difference between the Debt(current US$) of Congo (Republic) in 1991 and the Debt(current US$) of Maldives in 1995?
Make the answer very short. 3.37e+07. What is the difference between the Debt(current US$) in Congo (Republic) in 1991 and the Debt(current US$) in Panama in 1995?
Offer a very short reply. -2.53e+07. What is the difference between the Debt(current US$) of Maldives in 1991 and the Debt(current US$) of Panama in 1995?
Keep it short and to the point. -5.67e+07. What is the difference between the Debt(current US$) of Belize in 1991 and the Debt(current US$) of Congo (Republic) in 1996?
Provide a short and direct response. -1.46e+08. What is the difference between the Debt(current US$) in Belize in 1991 and the Debt(current US$) in Maldives in 1996?
Ensure brevity in your answer.  -1.86e+06. What is the difference between the Debt(current US$) in Belize in 1991 and the Debt(current US$) in Panama in 1996?
Keep it short and to the point. -1.20e+08. What is the difference between the Debt(current US$) in Congo (Republic) in 1991 and the Debt(current US$) in Maldives in 1996?
Make the answer very short. 2.97e+07. What is the difference between the Debt(current US$) of Congo (Republic) in 1991 and the Debt(current US$) of Panama in 1996?
Give a very brief answer. -8.88e+07. What is the difference between the Debt(current US$) in Maldives in 1991 and the Debt(current US$) in Panama in 1996?
Your answer should be compact. -1.20e+08. What is the difference between the Debt(current US$) in Belize in 1992 and the Debt(current US$) in Congo (Republic) in 1994?
Provide a succinct answer. -1.49e+08. What is the difference between the Debt(current US$) of Belize in 1992 and the Debt(current US$) of Maldives in 1994?
Your answer should be compact. -3.11e+06. What is the difference between the Debt(current US$) in Belize in 1992 and the Debt(current US$) in Panama in 1994?
Provide a short and direct response. -6.68e+06. What is the difference between the Debt(current US$) of Congo (Republic) in 1992 and the Debt(current US$) of Maldives in 1994?
Ensure brevity in your answer.  1.65e+07. What is the difference between the Debt(current US$) in Congo (Republic) in 1992 and the Debt(current US$) in Panama in 1994?
Provide a short and direct response. 1.29e+07. What is the difference between the Debt(current US$) of Maldives in 1992 and the Debt(current US$) of Panama in 1994?
Ensure brevity in your answer.  -4.73e+06. What is the difference between the Debt(current US$) of Belize in 1992 and the Debt(current US$) of Congo (Republic) in 1995?
Make the answer very short. -1.62e+08. What is the difference between the Debt(current US$) in Belize in 1992 and the Debt(current US$) in Maldives in 1995?
Provide a succinct answer. -2.96e+06. What is the difference between the Debt(current US$) of Belize in 1992 and the Debt(current US$) of Panama in 1995?
Keep it short and to the point. -6.20e+07. What is the difference between the Debt(current US$) in Congo (Republic) in 1992 and the Debt(current US$) in Maldives in 1995?
Keep it short and to the point. 1.66e+07. What is the difference between the Debt(current US$) of Congo (Republic) in 1992 and the Debt(current US$) of Panama in 1995?
Give a very brief answer. -4.24e+07. What is the difference between the Debt(current US$) in Maldives in 1992 and the Debt(current US$) in Panama in 1995?
Keep it short and to the point. -6.00e+07. What is the difference between the Debt(current US$) in Belize in 1992 and the Debt(current US$) in Congo (Republic) in 1996?
Provide a succinct answer. -1.52e+08. What is the difference between the Debt(current US$) of Belize in 1992 and the Debt(current US$) of Maldives in 1996?
Provide a short and direct response. -6.96e+06. What is the difference between the Debt(current US$) in Belize in 1992 and the Debt(current US$) in Panama in 1996?
Give a very brief answer. -1.25e+08. What is the difference between the Debt(current US$) of Congo (Republic) in 1992 and the Debt(current US$) of Maldives in 1996?
Keep it short and to the point. 1.26e+07. What is the difference between the Debt(current US$) of Congo (Republic) in 1992 and the Debt(current US$) of Panama in 1996?
Provide a succinct answer. -1.06e+08. What is the difference between the Debt(current US$) of Maldives in 1992 and the Debt(current US$) of Panama in 1996?
Your response must be concise. -1.23e+08. What is the difference between the Debt(current US$) in Belize in 1994 and the Debt(current US$) in Congo (Republic) in 1995?
Provide a succinct answer. -1.48e+08. What is the difference between the Debt(current US$) in Belize in 1994 and the Debt(current US$) in Maldives in 1995?
Give a very brief answer. 1.08e+07. What is the difference between the Debt(current US$) in Belize in 1994 and the Debt(current US$) in Panama in 1995?
Ensure brevity in your answer.  -4.82e+07. What is the difference between the Debt(current US$) of Congo (Republic) in 1994 and the Debt(current US$) of Maldives in 1995?
Offer a terse response. 1.46e+08. What is the difference between the Debt(current US$) in Congo (Republic) in 1994 and the Debt(current US$) in Panama in 1995?
Your answer should be compact. 8.73e+07. What is the difference between the Debt(current US$) of Maldives in 1994 and the Debt(current US$) of Panama in 1995?
Your response must be concise. -5.89e+07. What is the difference between the Debt(current US$) in Belize in 1994 and the Debt(current US$) in Congo (Republic) in 1996?
Provide a succinct answer. -1.38e+08. What is the difference between the Debt(current US$) in Belize in 1994 and the Debt(current US$) in Maldives in 1996?
Ensure brevity in your answer.  6.84e+06. What is the difference between the Debt(current US$) of Belize in 1994 and the Debt(current US$) of Panama in 1996?
Provide a succinct answer. -1.12e+08. What is the difference between the Debt(current US$) of Congo (Republic) in 1994 and the Debt(current US$) of Maldives in 1996?
Your answer should be compact. 1.42e+08. What is the difference between the Debt(current US$) of Congo (Republic) in 1994 and the Debt(current US$) of Panama in 1996?
Offer a terse response. 2.38e+07. What is the difference between the Debt(current US$) in Maldives in 1994 and the Debt(current US$) in Panama in 1996?
Give a very brief answer. -1.22e+08. What is the difference between the Debt(current US$) of Belize in 1995 and the Debt(current US$) of Congo (Republic) in 1996?
Offer a very short reply. -1.41e+08. What is the difference between the Debt(current US$) in Belize in 1995 and the Debt(current US$) in Maldives in 1996?
Provide a short and direct response. 3.60e+06. What is the difference between the Debt(current US$) of Belize in 1995 and the Debt(current US$) of Panama in 1996?
Your response must be concise. -1.15e+08. What is the difference between the Debt(current US$) of Congo (Republic) in 1995 and the Debt(current US$) of Maldives in 1996?
Offer a very short reply. 1.55e+08. What is the difference between the Debt(current US$) in Congo (Republic) in 1995 and the Debt(current US$) in Panama in 1996?
Keep it short and to the point. 3.66e+07. What is the difference between the Debt(current US$) in Maldives in 1995 and the Debt(current US$) in Panama in 1996?
Offer a terse response. -1.22e+08. What is the average Debt(current US$) of Belize per year?
Provide a succinct answer. 9.67e+06. What is the average Debt(current US$) of Congo (Republic) per year?
Give a very brief answer. 2.63e+08. What is the average Debt(current US$) in Maldives per year?
Provide a short and direct response. 4.30e+06. What is the average Debt(current US$) of Panama per year?
Your answer should be compact. 3.37e+07. In the year 1988, what is the difference between the Debt(current US$) in Belize and Debt(current US$) in Congo (Republic)?
Keep it short and to the point. -9.22e+08. In the year 1988, what is the difference between the Debt(current US$) of Belize and Debt(current US$) of Maldives?
Offer a very short reply. -2.64e+05. In the year 1988, what is the difference between the Debt(current US$) of Belize and Debt(current US$) of Panama?
Give a very brief answer. -3.32e+07. In the year 1988, what is the difference between the Debt(current US$) of Congo (Republic) and Debt(current US$) of Maldives?
Offer a terse response. 9.21e+08. In the year 1988, what is the difference between the Debt(current US$) of Congo (Republic) and Debt(current US$) of Panama?
Make the answer very short. 8.89e+08. In the year 1988, what is the difference between the Debt(current US$) in Maldives and Debt(current US$) in Panama?
Provide a short and direct response. -3.29e+07. In the year 1989, what is the difference between the Debt(current US$) in Belize and Debt(current US$) in Congo (Republic)?
Offer a terse response. -5.50e+08. In the year 1989, what is the difference between the Debt(current US$) of Belize and Debt(current US$) of Maldives?
Your answer should be compact. 1.75e+07. In the year 1989, what is the difference between the Debt(current US$) of Belize and Debt(current US$) of Panama?
Offer a very short reply. 1.39e+07. In the year 1989, what is the difference between the Debt(current US$) in Congo (Republic) and Debt(current US$) in Maldives?
Provide a succinct answer. 5.68e+08. In the year 1989, what is the difference between the Debt(current US$) in Congo (Republic) and Debt(current US$) in Panama?
Offer a very short reply. 5.64e+08. In the year 1989, what is the difference between the Debt(current US$) of Maldives and Debt(current US$) of Panama?
Provide a succinct answer. -3.58e+06. In the year 1990, what is the difference between the Debt(current US$) in Belize and Debt(current US$) in Congo (Republic)?
Give a very brief answer. -7.14e+07. In the year 1990, what is the difference between the Debt(current US$) of Belize and Debt(current US$) of Maldives?
Ensure brevity in your answer.  9.40e+06. In the year 1990, what is the difference between the Debt(current US$) of Belize and Debt(current US$) of Panama?
Give a very brief answer. 3.24e+06. In the year 1990, what is the difference between the Debt(current US$) of Congo (Republic) and Debt(current US$) of Maldives?
Provide a short and direct response. 8.08e+07. In the year 1990, what is the difference between the Debt(current US$) of Congo (Republic) and Debt(current US$) of Panama?
Offer a terse response. 7.46e+07. In the year 1990, what is the difference between the Debt(current US$) in Maldives and Debt(current US$) in Panama?
Your response must be concise. -6.16e+06. In the year 1991, what is the difference between the Debt(current US$) in Belize and Debt(current US$) in Congo (Republic)?
Provide a short and direct response. -3.16e+07. In the year 1991, what is the difference between the Debt(current US$) of Belize and Debt(current US$) of Maldives?
Keep it short and to the point. -2.01e+05. In the year 1991, what is the difference between the Debt(current US$) of Belize and Debt(current US$) of Panama?
Keep it short and to the point. -1.51e+06. In the year 1991, what is the difference between the Debt(current US$) of Congo (Republic) and Debt(current US$) of Maldives?
Provide a succinct answer. 3.14e+07. In the year 1991, what is the difference between the Debt(current US$) in Congo (Republic) and Debt(current US$) in Panama?
Provide a succinct answer. 3.01e+07. In the year 1991, what is the difference between the Debt(current US$) of Maldives and Debt(current US$) of Panama?
Provide a succinct answer. -1.31e+06. In the year 1992, what is the difference between the Debt(current US$) in Belize and Debt(current US$) in Congo (Republic)?
Offer a terse response. -1.96e+07. In the year 1992, what is the difference between the Debt(current US$) in Belize and Debt(current US$) in Maldives?
Provide a succinct answer. -1.95e+06. In the year 1992, what is the difference between the Debt(current US$) in Belize and Debt(current US$) in Panama?
Ensure brevity in your answer.  -1.23e+07. In the year 1992, what is the difference between the Debt(current US$) in Congo (Republic) and Debt(current US$) in Maldives?
Offer a terse response. 1.77e+07. In the year 1992, what is the difference between the Debt(current US$) in Congo (Republic) and Debt(current US$) in Panama?
Make the answer very short. 7.27e+06. In the year 1992, what is the difference between the Debt(current US$) of Maldives and Debt(current US$) of Panama?
Ensure brevity in your answer.  -1.04e+07. In the year 1994, what is the difference between the Debt(current US$) of Belize and Debt(current US$) of Congo (Republic)?
Keep it short and to the point. -1.35e+08. In the year 1994, what is the difference between the Debt(current US$) of Belize and Debt(current US$) of Maldives?
Ensure brevity in your answer.  1.07e+07. In the year 1994, what is the difference between the Debt(current US$) in Belize and Debt(current US$) in Panama?
Keep it short and to the point. 7.12e+06. In the year 1994, what is the difference between the Debt(current US$) in Congo (Republic) and Debt(current US$) in Maldives?
Provide a succinct answer. 1.46e+08. In the year 1994, what is the difference between the Debt(current US$) in Congo (Republic) and Debt(current US$) in Panama?
Your answer should be compact. 1.43e+08. In the year 1994, what is the difference between the Debt(current US$) of Maldives and Debt(current US$) of Panama?
Offer a very short reply. -3.57e+06. In the year 1995, what is the difference between the Debt(current US$) in Belize and Debt(current US$) in Congo (Republic)?
Provide a succinct answer. -1.51e+08. In the year 1995, what is the difference between the Debt(current US$) of Belize and Debt(current US$) of Maldives?
Ensure brevity in your answer.  7.60e+06. In the year 1995, what is the difference between the Debt(current US$) in Belize and Debt(current US$) in Panama?
Provide a short and direct response. -5.14e+07. In the year 1995, what is the difference between the Debt(current US$) of Congo (Republic) and Debt(current US$) of Maldives?
Offer a terse response. 1.59e+08. In the year 1995, what is the difference between the Debt(current US$) of Congo (Republic) and Debt(current US$) of Panama?
Give a very brief answer. 1.00e+08. In the year 1995, what is the difference between the Debt(current US$) in Maldives and Debt(current US$) in Panama?
Provide a short and direct response. -5.90e+07. In the year 1996, what is the difference between the Debt(current US$) in Belize and Debt(current US$) in Congo (Republic)?
Your answer should be compact. -1.44e+08. In the year 1996, what is the difference between the Debt(current US$) of Belize and Debt(current US$) of Maldives?
Your response must be concise. 1.23e+05. In the year 1996, what is the difference between the Debt(current US$) of Belize and Debt(current US$) of Panama?
Your answer should be compact. -1.18e+08. In the year 1996, what is the difference between the Debt(current US$) of Congo (Republic) and Debt(current US$) of Maldives?
Your answer should be compact. 1.45e+08. In the year 1996, what is the difference between the Debt(current US$) of Congo (Republic) and Debt(current US$) of Panama?
Give a very brief answer. 2.61e+07. In the year 1996, what is the difference between the Debt(current US$) of Maldives and Debt(current US$) of Panama?
Provide a short and direct response. -1.18e+08. What is the ratio of the Debt(current US$) in Belize in 1988 to that in 1989?
Offer a terse response. 0.06. What is the ratio of the Debt(current US$) in Congo (Republic) in 1988 to that in 1989?
Your answer should be compact. 1.61. What is the ratio of the Debt(current US$) in Maldives in 1988 to that in 1989?
Provide a succinct answer. 0.34. What is the ratio of the Debt(current US$) of Panama in 1988 to that in 1989?
Provide a short and direct response. 4.17. What is the ratio of the Debt(current US$) in Belize in 1988 to that in 1990?
Make the answer very short. 0.12. What is the ratio of the Debt(current US$) of Congo (Republic) in 1988 to that in 1990?
Your answer should be very brief. 11.19. What is the ratio of the Debt(current US$) of Maldives in 1988 to that in 1990?
Offer a very short reply. 0.94. What is the ratio of the Debt(current US$) in Panama in 1988 to that in 1990?
Give a very brief answer. 4.39. What is the ratio of the Debt(current US$) of Belize in 1988 to that in 1991?
Provide a succinct answer. 0.21. What is the ratio of the Debt(current US$) of Congo (Republic) in 1988 to that in 1991?
Provide a short and direct response. 24.35. What is the ratio of the Debt(current US$) of Maldives in 1988 to that in 1991?
Make the answer very short. 0.24. What is the ratio of the Debt(current US$) in Panama in 1988 to that in 1991?
Make the answer very short. 4.4. What is the ratio of the Debt(current US$) in Belize in 1988 to that in 1992?
Provide a short and direct response. 1.07. What is the ratio of the Debt(current US$) in Congo (Republic) in 1988 to that in 1992?
Your answer should be very brief. 44.28. What is the ratio of the Debt(current US$) of Maldives in 1988 to that in 1992?
Your answer should be compact. 0.5. What is the ratio of the Debt(current US$) in Panama in 1988 to that in 1992?
Provide a short and direct response. 2.54. What is the ratio of the Debt(current US$) in Belize in 1988 to that in 1994?
Offer a terse response. 0.09. What is the ratio of the Debt(current US$) in Congo (Republic) in 1988 to that in 1994?
Offer a very short reply. 6.13. What is the ratio of the Debt(current US$) in Maldives in 1988 to that in 1994?
Provide a short and direct response. 0.36. What is the ratio of the Debt(current US$) of Panama in 1988 to that in 1994?
Your answer should be compact. 4.36. What is the ratio of the Debt(current US$) in Belize in 1988 to that in 1995?
Your response must be concise. 0.11. What is the ratio of the Debt(current US$) of Congo (Republic) in 1988 to that in 1995?
Offer a terse response. 5.65. What is the ratio of the Debt(current US$) in Maldives in 1988 to that in 1995?
Keep it short and to the point. 0.38. What is the ratio of the Debt(current US$) in Panama in 1988 to that in 1995?
Ensure brevity in your answer.  0.55. What is the ratio of the Debt(current US$) in Belize in 1988 to that in 1996?
Offer a terse response. 0.16. What is the ratio of the Debt(current US$) of Congo (Republic) in 1988 to that in 1996?
Your response must be concise. 6.04. What is the ratio of the Debt(current US$) in Maldives in 1988 to that in 1996?
Provide a short and direct response. 0.19. What is the ratio of the Debt(current US$) in Panama in 1988 to that in 1996?
Offer a very short reply. 0.27. What is the ratio of the Debt(current US$) in Belize in 1989 to that in 1990?
Provide a short and direct response. 2. What is the ratio of the Debt(current US$) in Congo (Republic) in 1989 to that in 1990?
Keep it short and to the point. 6.94. What is the ratio of the Debt(current US$) in Maldives in 1989 to that in 1990?
Your answer should be very brief. 2.77. What is the ratio of the Debt(current US$) in Panama in 1989 to that in 1990?
Provide a short and direct response. 1.05. What is the ratio of the Debt(current US$) of Belize in 1989 to that in 1991?
Provide a short and direct response. 3.5. What is the ratio of the Debt(current US$) in Congo (Republic) in 1989 to that in 1991?
Your answer should be compact. 15.1. What is the ratio of the Debt(current US$) in Maldives in 1989 to that in 1991?
Offer a very short reply. 0.72. What is the ratio of the Debt(current US$) of Panama in 1989 to that in 1991?
Provide a short and direct response. 1.05. What is the ratio of the Debt(current US$) of Belize in 1989 to that in 1992?
Your response must be concise. 17.9. What is the ratio of the Debt(current US$) in Congo (Republic) in 1989 to that in 1992?
Give a very brief answer. 27.46. What is the ratio of the Debt(current US$) of Maldives in 1989 to that in 1992?
Keep it short and to the point. 1.47. What is the ratio of the Debt(current US$) in Panama in 1989 to that in 1992?
Offer a terse response. 0.61. What is the ratio of the Debt(current US$) of Belize in 1989 to that in 1994?
Provide a succinct answer. 1.48. What is the ratio of the Debt(current US$) of Congo (Republic) in 1989 to that in 1994?
Your response must be concise. 3.8. What is the ratio of the Debt(current US$) in Maldives in 1989 to that in 1994?
Make the answer very short. 1.08. What is the ratio of the Debt(current US$) of Panama in 1989 to that in 1994?
Your response must be concise. 1.04. What is the ratio of the Debt(current US$) of Belize in 1989 to that in 1995?
Keep it short and to the point. 1.88. What is the ratio of the Debt(current US$) in Congo (Republic) in 1989 to that in 1995?
Your answer should be compact. 3.51. What is the ratio of the Debt(current US$) of Maldives in 1989 to that in 1995?
Offer a very short reply. 1.12. What is the ratio of the Debt(current US$) in Panama in 1989 to that in 1995?
Offer a terse response. 0.13. What is the ratio of the Debt(current US$) in Belize in 1989 to that in 1996?
Give a very brief answer. 2.67. What is the ratio of the Debt(current US$) of Congo (Republic) in 1989 to that in 1996?
Offer a very short reply. 3.75. What is the ratio of the Debt(current US$) of Maldives in 1989 to that in 1996?
Give a very brief answer. 0.57. What is the ratio of the Debt(current US$) of Panama in 1989 to that in 1996?
Offer a terse response. 0.07. What is the ratio of the Debt(current US$) of Belize in 1990 to that in 1991?
Give a very brief answer. 1.75. What is the ratio of the Debt(current US$) in Congo (Republic) in 1990 to that in 1991?
Offer a terse response. 2.18. What is the ratio of the Debt(current US$) in Maldives in 1990 to that in 1991?
Make the answer very short. 0.26. What is the ratio of the Debt(current US$) in Panama in 1990 to that in 1991?
Provide a succinct answer. 1. What is the ratio of the Debt(current US$) of Belize in 1990 to that in 1992?
Offer a terse response. 8.94. What is the ratio of the Debt(current US$) in Congo (Republic) in 1990 to that in 1992?
Ensure brevity in your answer.  3.96. What is the ratio of the Debt(current US$) of Maldives in 1990 to that in 1992?
Make the answer very short. 0.53. What is the ratio of the Debt(current US$) of Panama in 1990 to that in 1992?
Your response must be concise. 0.58. What is the ratio of the Debt(current US$) in Belize in 1990 to that in 1994?
Provide a succinct answer. 0.74. What is the ratio of the Debt(current US$) of Congo (Republic) in 1990 to that in 1994?
Keep it short and to the point. 0.55. What is the ratio of the Debt(current US$) in Maldives in 1990 to that in 1994?
Your response must be concise. 0.39. What is the ratio of the Debt(current US$) in Panama in 1990 to that in 1994?
Your answer should be compact. 0.99. What is the ratio of the Debt(current US$) in Belize in 1990 to that in 1995?
Your answer should be very brief. 0.94. What is the ratio of the Debt(current US$) of Congo (Republic) in 1990 to that in 1995?
Keep it short and to the point. 0.51. What is the ratio of the Debt(current US$) in Maldives in 1990 to that in 1995?
Your answer should be very brief. 0.4. What is the ratio of the Debt(current US$) in Panama in 1990 to that in 1995?
Your answer should be very brief. 0.12. What is the ratio of the Debt(current US$) in Belize in 1990 to that in 1996?
Provide a succinct answer. 1.33. What is the ratio of the Debt(current US$) of Congo (Republic) in 1990 to that in 1996?
Give a very brief answer. 0.54. What is the ratio of the Debt(current US$) in Maldives in 1990 to that in 1996?
Your answer should be very brief. 0.21. What is the ratio of the Debt(current US$) in Panama in 1990 to that in 1996?
Your answer should be very brief. 0.06. What is the ratio of the Debt(current US$) in Belize in 1991 to that in 1992?
Your answer should be compact. 5.11. What is the ratio of the Debt(current US$) of Congo (Republic) in 1991 to that in 1992?
Offer a very short reply. 1.82. What is the ratio of the Debt(current US$) of Maldives in 1991 to that in 1992?
Offer a very short reply. 2.05. What is the ratio of the Debt(current US$) of Panama in 1991 to that in 1992?
Offer a terse response. 0.58. What is the ratio of the Debt(current US$) in Belize in 1991 to that in 1994?
Keep it short and to the point. 0.42. What is the ratio of the Debt(current US$) of Congo (Republic) in 1991 to that in 1994?
Your answer should be very brief. 0.25. What is the ratio of the Debt(current US$) of Maldives in 1991 to that in 1994?
Make the answer very short. 1.5. What is the ratio of the Debt(current US$) of Belize in 1991 to that in 1995?
Make the answer very short. 0.54. What is the ratio of the Debt(current US$) in Congo (Republic) in 1991 to that in 1995?
Ensure brevity in your answer.  0.23. What is the ratio of the Debt(current US$) of Maldives in 1991 to that in 1995?
Give a very brief answer. 1.56. What is the ratio of the Debt(current US$) of Panama in 1991 to that in 1995?
Provide a succinct answer. 0.12. What is the ratio of the Debt(current US$) in Belize in 1991 to that in 1996?
Offer a terse response. 0.76. What is the ratio of the Debt(current US$) in Congo (Republic) in 1991 to that in 1996?
Your answer should be very brief. 0.25. What is the ratio of the Debt(current US$) in Maldives in 1991 to that in 1996?
Your response must be concise. 0.8. What is the ratio of the Debt(current US$) in Panama in 1991 to that in 1996?
Provide a short and direct response. 0.06. What is the ratio of the Debt(current US$) in Belize in 1992 to that in 1994?
Ensure brevity in your answer.  0.08. What is the ratio of the Debt(current US$) of Congo (Republic) in 1992 to that in 1994?
Provide a short and direct response. 0.14. What is the ratio of the Debt(current US$) in Maldives in 1992 to that in 1994?
Make the answer very short. 0.73. What is the ratio of the Debt(current US$) of Panama in 1992 to that in 1994?
Provide a succinct answer. 1.71. What is the ratio of the Debt(current US$) of Belize in 1992 to that in 1995?
Provide a short and direct response. 0.11. What is the ratio of the Debt(current US$) in Congo (Republic) in 1992 to that in 1995?
Provide a succinct answer. 0.13. What is the ratio of the Debt(current US$) in Maldives in 1992 to that in 1995?
Keep it short and to the point. 0.76. What is the ratio of the Debt(current US$) of Panama in 1992 to that in 1995?
Your answer should be compact. 0.21. What is the ratio of the Debt(current US$) in Belize in 1992 to that in 1996?
Give a very brief answer. 0.15. What is the ratio of the Debt(current US$) of Congo (Republic) in 1992 to that in 1996?
Ensure brevity in your answer.  0.14. What is the ratio of the Debt(current US$) in Maldives in 1992 to that in 1996?
Ensure brevity in your answer.  0.39. What is the ratio of the Debt(current US$) in Panama in 1992 to that in 1996?
Keep it short and to the point. 0.11. What is the ratio of the Debt(current US$) in Belize in 1994 to that in 1995?
Ensure brevity in your answer.  1.28. What is the ratio of the Debt(current US$) of Congo (Republic) in 1994 to that in 1995?
Provide a short and direct response. 0.92. What is the ratio of the Debt(current US$) of Maldives in 1994 to that in 1995?
Your answer should be compact. 1.04. What is the ratio of the Debt(current US$) of Panama in 1994 to that in 1995?
Your answer should be compact. 0.13. What is the ratio of the Debt(current US$) of Belize in 1994 to that in 1996?
Ensure brevity in your answer.  1.81. What is the ratio of the Debt(current US$) in Congo (Republic) in 1994 to that in 1996?
Give a very brief answer. 0.99. What is the ratio of the Debt(current US$) in Maldives in 1994 to that in 1996?
Your response must be concise. 0.53. What is the ratio of the Debt(current US$) in Panama in 1994 to that in 1996?
Provide a short and direct response. 0.06. What is the ratio of the Debt(current US$) in Belize in 1995 to that in 1996?
Offer a terse response. 1.42. What is the ratio of the Debt(current US$) of Congo (Republic) in 1995 to that in 1996?
Provide a succinct answer. 1.07. What is the ratio of the Debt(current US$) in Maldives in 1995 to that in 1996?
Offer a very short reply. 0.51. What is the ratio of the Debt(current US$) in Panama in 1995 to that in 1996?
Your response must be concise. 0.5. What is the difference between the highest and the second highest Debt(current US$) of Belize?
Give a very brief answer. 7.16e+06. What is the difference between the highest and the second highest Debt(current US$) of Congo (Republic)?
Ensure brevity in your answer.  3.51e+08. What is the difference between the highest and the second highest Debt(current US$) of Maldives?
Your answer should be compact. 1.66e+06. What is the difference between the highest and the second highest Debt(current US$) in Panama?
Your answer should be compact. 6.35e+07. What is the difference between the highest and the lowest Debt(current US$) in Belize?
Offer a terse response. 2.10e+07. What is the difference between the highest and the lowest Debt(current US$) of Congo (Republic)?
Your answer should be compact. 9.02e+08. What is the difference between the highest and the lowest Debt(current US$) in Maldives?
Your response must be concise. 6.62e+06. What is the difference between the highest and the lowest Debt(current US$) of Panama?
Ensure brevity in your answer.  1.19e+08. 